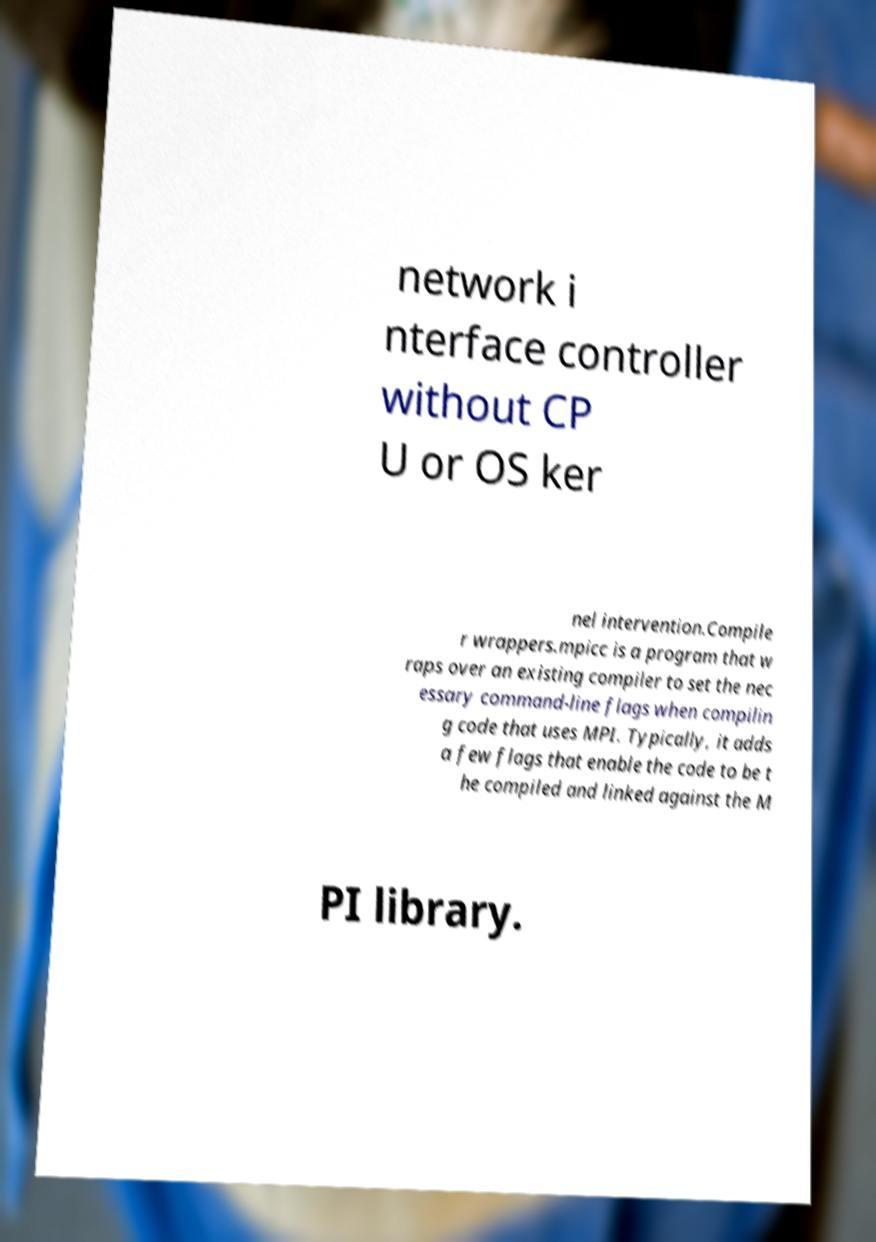What messages or text are displayed in this image? I need them in a readable, typed format. network i nterface controller without CP U or OS ker nel intervention.Compile r wrappers.mpicc is a program that w raps over an existing compiler to set the nec essary command-line flags when compilin g code that uses MPI. Typically, it adds a few flags that enable the code to be t he compiled and linked against the M PI library. 